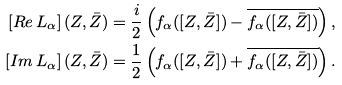Convert formula to latex. <formula><loc_0><loc_0><loc_500><loc_500>\left [ R e \, L _ { \alpha } \right ] ( Z , \bar { Z } ) & = \frac { i } { 2 } \left ( f _ { \alpha } ( [ Z , \bar { Z } ] ) - \overline { f _ { \alpha } ( [ Z , \bar { Z } ] ) } \right ) , \\ \left [ I m \, L _ { \alpha } \right ] ( Z , \bar { Z } ) & = \frac { 1 } { 2 } \left ( f _ { \alpha } ( [ Z , \bar { Z } ] ) + \overline { f _ { \alpha } ( [ Z , \bar { Z } ] ) } \right ) .</formula> 